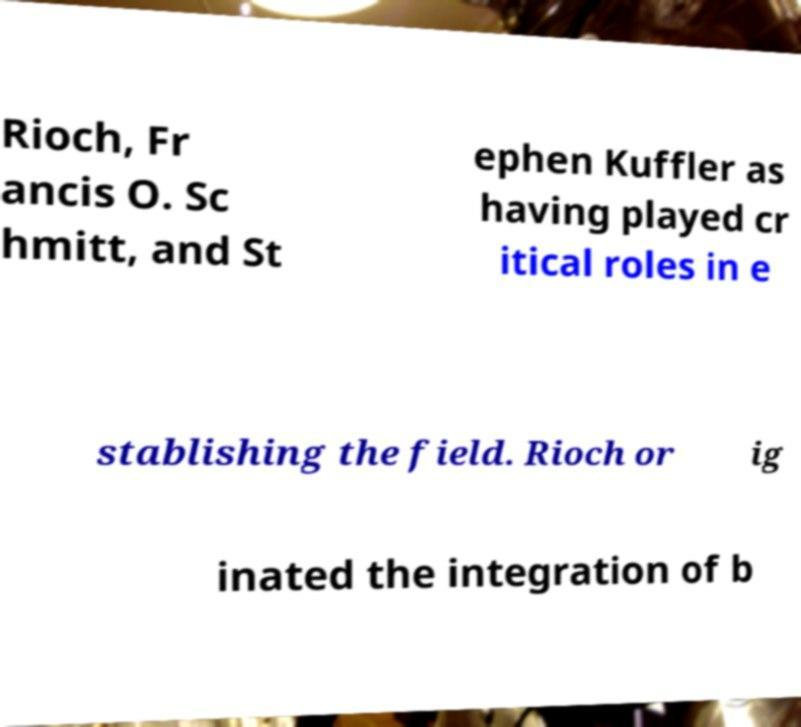Please identify and transcribe the text found in this image. Rioch, Fr ancis O. Sc hmitt, and St ephen Kuffler as having played cr itical roles in e stablishing the field. Rioch or ig inated the integration of b 